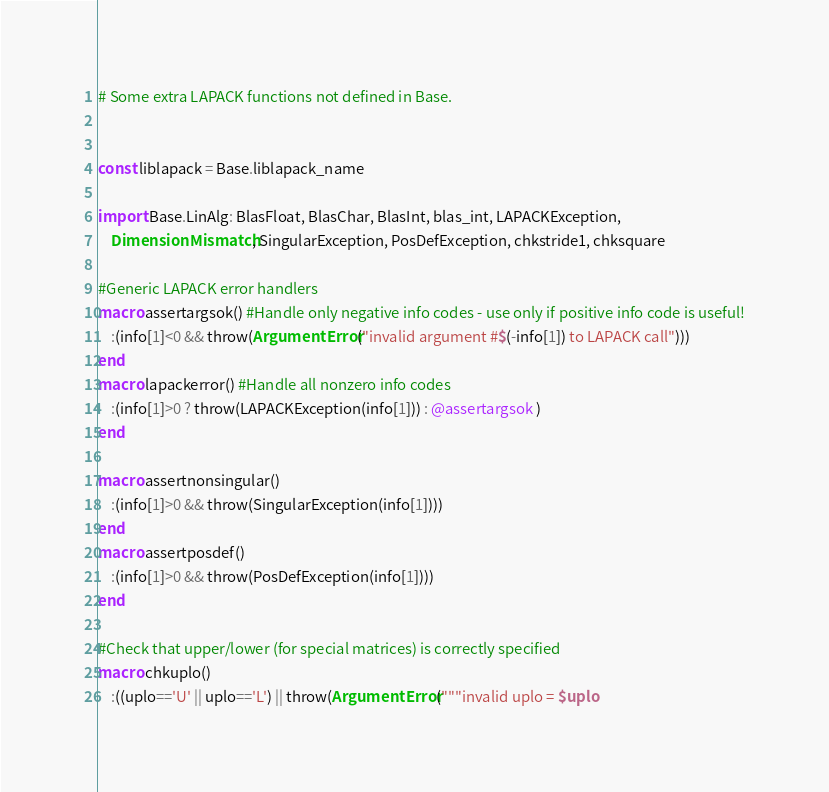<code> <loc_0><loc_0><loc_500><loc_500><_Julia_># Some extra LAPACK functions not defined in Base.


const liblapack = Base.liblapack_name

import Base.LinAlg: BlasFloat, BlasChar, BlasInt, blas_int, LAPACKException,
    DimensionMismatch, SingularException, PosDefException, chkstride1, chksquare

#Generic LAPACK error handlers
macro assertargsok() #Handle only negative info codes - use only if positive info code is useful!
    :(info[1]<0 && throw(ArgumentError("invalid argument #$(-info[1]) to LAPACK call")))
end
macro lapackerror() #Handle all nonzero info codes
    :(info[1]>0 ? throw(LAPACKException(info[1])) : @assertargsok )
end

macro assertnonsingular()
    :(info[1]>0 && throw(SingularException(info[1])))
end
macro assertposdef()
    :(info[1]>0 && throw(PosDefException(info[1])))
end

#Check that upper/lower (for special matrices) is correctly specified
macro chkuplo()
    :((uplo=='U' || uplo=='L') || throw(ArgumentError("""invalid uplo = $uplo
</code> 